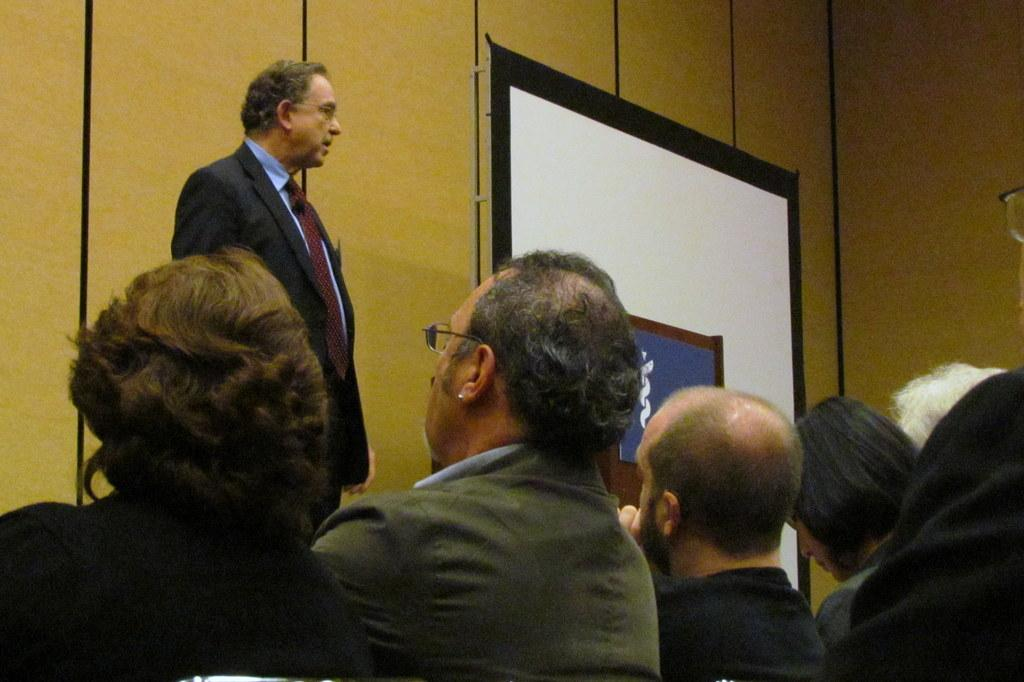Who or what can be seen at the bottom of the image? There are persons at the bottom of the image. What can be seen in the background of the image? There is a man standing, a wall, a podium, a board, and a pole in the background of the image. Can you describe the man's position in the image? The man is standing in the background of the image. What type of chess piece is the man holding in the image? There is no chess piece present in the image; the man is standing without holding any object. How many feet are visible in the image? The number of feet visible in the image cannot be determined from the provided facts, as the focus is on the persons and objects in the image, not their body parts. 